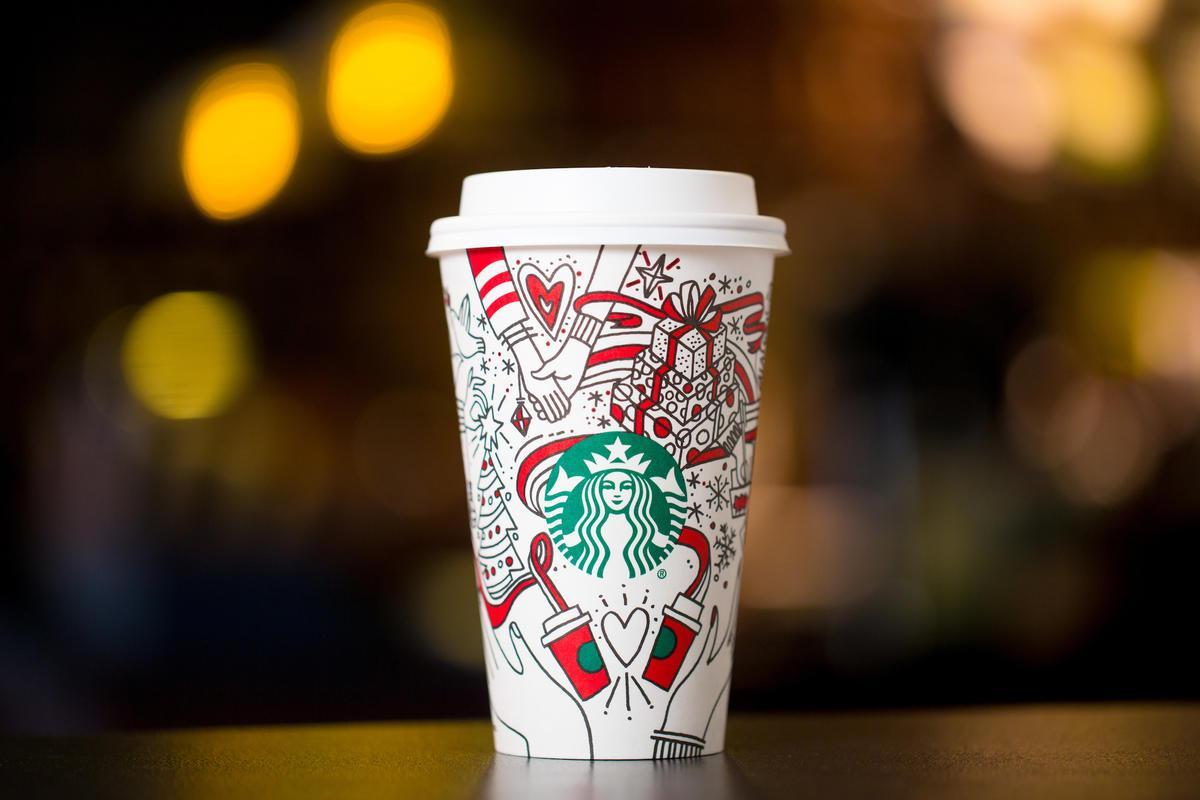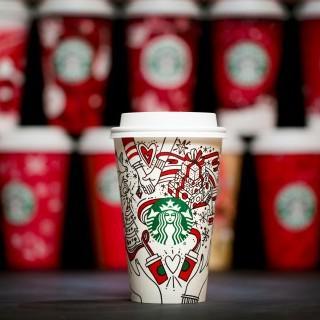The first image is the image on the left, the second image is the image on the right. For the images displayed, is the sentence "In both images a person is holding a cup in their hand." factually correct? Answer yes or no. No. 